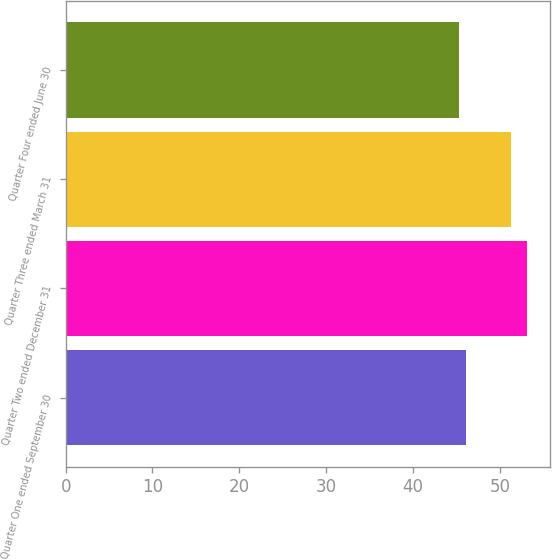Convert chart to OTSL. <chart><loc_0><loc_0><loc_500><loc_500><bar_chart><fcel>Quarter One ended September 30<fcel>Quarter Two ended December 31<fcel>Quarter Three ended March 31<fcel>Quarter Four ended June 30<nl><fcel>46.1<fcel>53.09<fcel>51.31<fcel>45.32<nl></chart> 